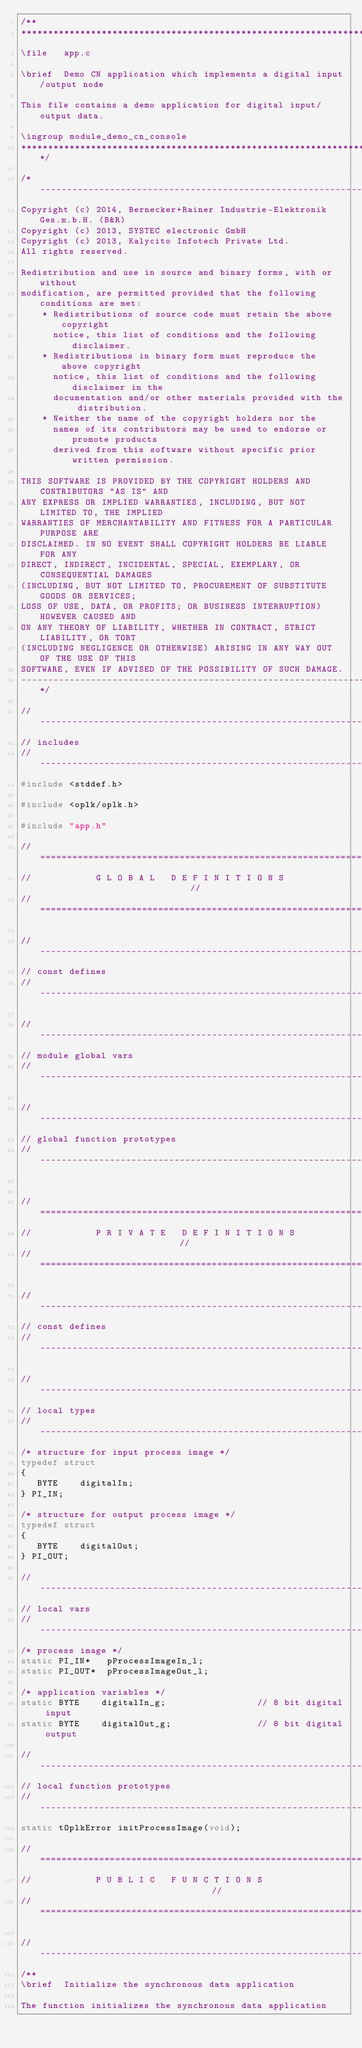Convert code to text. <code><loc_0><loc_0><loc_500><loc_500><_C_>/**
********************************************************************************
\file   app.c

\brief  Demo CN application which implements a digital input/output node

This file contains a demo application for digital input/output data.

\ingroup module_demo_cn_console
*******************************************************************************/

/*------------------------------------------------------------------------------
Copyright (c) 2014, Bernecker+Rainer Industrie-Elektronik Ges.m.b.H. (B&R)
Copyright (c) 2013, SYSTEC electronic GmbH
Copyright (c) 2013, Kalycito Infotech Private Ltd.
All rights reserved.

Redistribution and use in source and binary forms, with or without
modification, are permitted provided that the following conditions are met:
    * Redistributions of source code must retain the above copyright
      notice, this list of conditions and the following disclaimer.
    * Redistributions in binary form must reproduce the above copyright
      notice, this list of conditions and the following disclaimer in the
      documentation and/or other materials provided with the distribution.
    * Neither the name of the copyright holders nor the
      names of its contributors may be used to endorse or promote products
      derived from this software without specific prior written permission.

THIS SOFTWARE IS PROVIDED BY THE COPYRIGHT HOLDERS AND CONTRIBUTORS "AS IS" AND
ANY EXPRESS OR IMPLIED WARRANTIES, INCLUDING, BUT NOT LIMITED TO, THE IMPLIED
WARRANTIES OF MERCHANTABILITY AND FITNESS FOR A PARTICULAR PURPOSE ARE
DISCLAIMED. IN NO EVENT SHALL COPYRIGHT HOLDERS BE LIABLE FOR ANY
DIRECT, INDIRECT, INCIDENTAL, SPECIAL, EXEMPLARY, OR CONSEQUENTIAL DAMAGES
(INCLUDING, BUT NOT LIMITED TO, PROCUREMENT OF SUBSTITUTE GOODS OR SERVICES;
LOSS OF USE, DATA, OR PROFITS; OR BUSINESS INTERRUPTION) HOWEVER CAUSED AND
ON ANY THEORY OF LIABILITY, WHETHER IN CONTRACT, STRICT LIABILITY, OR TORT
(INCLUDING NEGLIGENCE OR OTHERWISE) ARISING IN ANY WAY OUT OF THE USE OF THIS
SOFTWARE, EVEN IF ADVISED OF THE POSSIBILITY OF SUCH DAMAGE.
------------------------------------------------------------------------------*/

//------------------------------------------------------------------------------
// includes
//------------------------------------------------------------------------------
#include <stddef.h>

#include <oplk/oplk.h>

#include "app.h"

//============================================================================//
//            G L O B A L   D E F I N I T I O N S                             //
//============================================================================//

//------------------------------------------------------------------------------
// const defines
//------------------------------------------------------------------------------

//------------------------------------------------------------------------------
// module global vars
//------------------------------------------------------------------------------

//------------------------------------------------------------------------------
// global function prototypes
//------------------------------------------------------------------------------


//============================================================================//
//            P R I V A T E   D E F I N I T I O N S                           //
//============================================================================//

//------------------------------------------------------------------------------
// const defines
//------------------------------------------------------------------------------

//------------------------------------------------------------------------------
// local types
//------------------------------------------------------------------------------
/* structure for input process image */
typedef struct
{
   BYTE    digitalIn;
} PI_IN;

/* structure for output process image */
typedef struct
{
   BYTE    digitalOut;
} PI_OUT;

//------------------------------------------------------------------------------
// local vars
//------------------------------------------------------------------------------
/* process image */
static PI_IN*   pProcessImageIn_l;
static PI_OUT*  pProcessImageOut_l;

/* application variables */
static BYTE    digitalIn_g;                 // 8 bit digital input
static BYTE    digitalOut_g;                // 8 bit digital output

//------------------------------------------------------------------------------
// local function prototypes
//------------------------------------------------------------------------------
static tOplkError initProcessImage(void);

//============================================================================//
//            P U B L I C   F U N C T I O N S                                 //
//============================================================================//

//------------------------------------------------------------------------------
/**
\brief  Initialize the synchronous data application

The function initializes the synchronous data application
</code> 